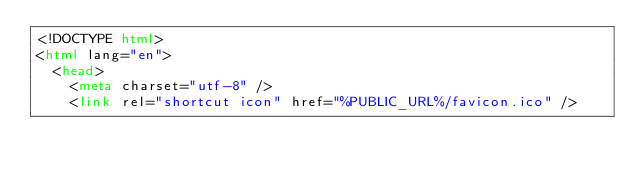<code> <loc_0><loc_0><loc_500><loc_500><_HTML_><!DOCTYPE html>
<html lang="en">
  <head>
    <meta charset="utf-8" />
    <link rel="shortcut icon" href="%PUBLIC_URL%/favicon.ico" /></code> 